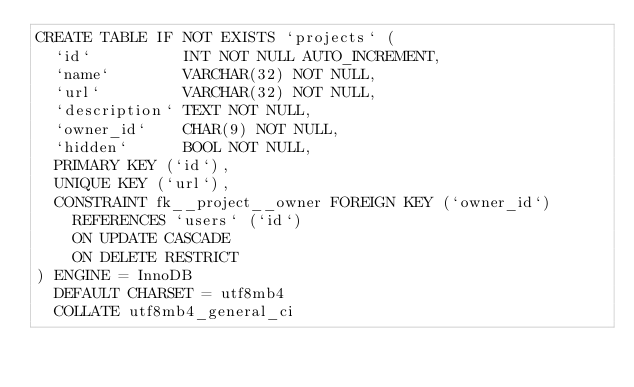<code> <loc_0><loc_0><loc_500><loc_500><_SQL_>CREATE TABLE IF NOT EXISTS `projects` (
	`id`          INT NOT NULL AUTO_INCREMENT,
	`name`        VARCHAR(32) NOT NULL,
	`url`         VARCHAR(32) NOT NULL,
	`description` TEXT NOT NULL,
	`owner_id`    CHAR(9) NOT NULL,
	`hidden`      BOOL NOT NULL,
	PRIMARY KEY (`id`),
	UNIQUE KEY (`url`),
	CONSTRAINT fk__project__owner FOREIGN KEY (`owner_id`)
		REFERENCES `users` (`id`)
		ON UPDATE CASCADE
		ON DELETE RESTRICT
) ENGINE = InnoDB
  DEFAULT CHARSET = utf8mb4
  COLLATE utf8mb4_general_ci
</code> 